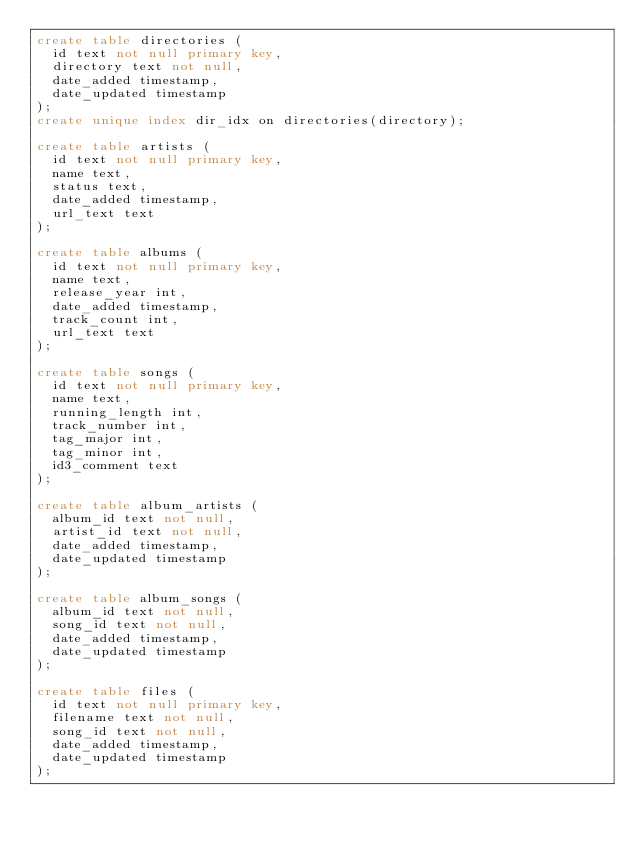<code> <loc_0><loc_0><loc_500><loc_500><_SQL_>create table directories (
  id text not null primary key,
  directory text not null,
  date_added timestamp,
  date_updated timestamp
);
create unique index dir_idx on directories(directory);

create table artists (
  id text not null primary key,
  name text,
  status text,
  date_added timestamp,
  url_text text
);

create table albums (
  id text not null primary key,
  name text,
  release_year int,
  date_added timestamp,
  track_count int,
  url_text text
);

create table songs (
  id text not null primary key,
  name text,
  running_length int,
  track_number int,
  tag_major int,
  tag_minor int,
  id3_comment text
);

create table album_artists (
  album_id text not null,
  artist_id text not null,
  date_added timestamp,
  date_updated timestamp
);

create table album_songs (
  album_id text not null,
  song_id text not null,
  date_added timestamp,
  date_updated timestamp
);

create table files (
  id text not null primary key,
  filename text not null,
  song_id text not null,
  date_added timestamp,
  date_updated timestamp
);
</code> 